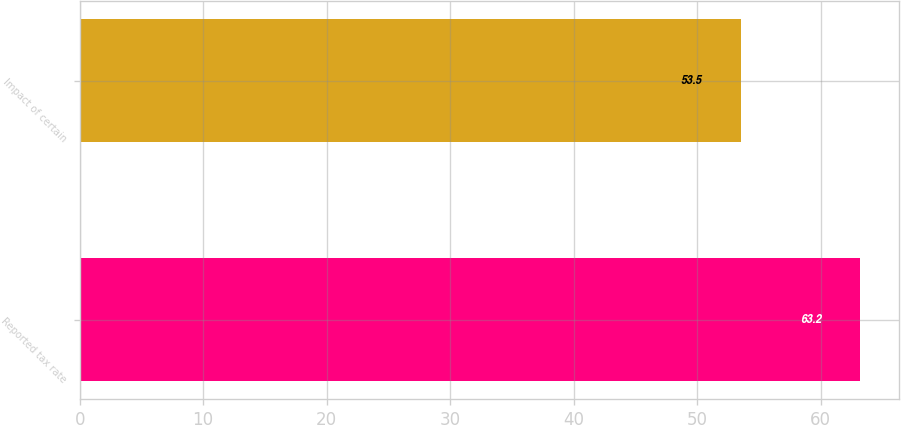Convert chart. <chart><loc_0><loc_0><loc_500><loc_500><bar_chart><fcel>Reported tax rate<fcel>Impact of certain<nl><fcel>63.2<fcel>53.5<nl></chart> 